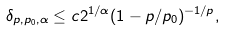Convert formula to latex. <formula><loc_0><loc_0><loc_500><loc_500>\delta _ { p , p _ { 0 } , \alpha } \leq c 2 ^ { 1 / \alpha } ( 1 - p / p _ { 0 } ) ^ { - 1 / p } ,</formula> 